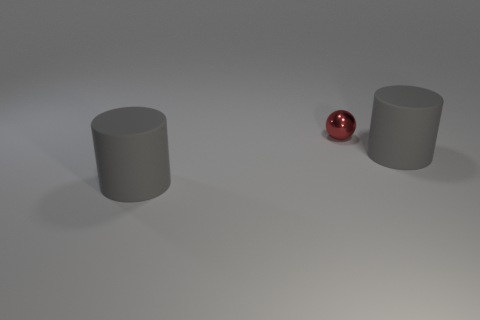How is the lighting in this image? The image is lit in a way that creates a soft shadow below each object, indicating a diffused light source overhead. The reflective nature of the ball captures the light, highlighting its curvature, while the cylinders show subtle gradients, suggesting a tranquil atmosphere. 